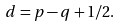Convert formula to latex. <formula><loc_0><loc_0><loc_500><loc_500>d = p - q + 1 / 2 .</formula> 